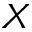Convert formula to latex. <formula><loc_0><loc_0><loc_500><loc_500>X</formula> 